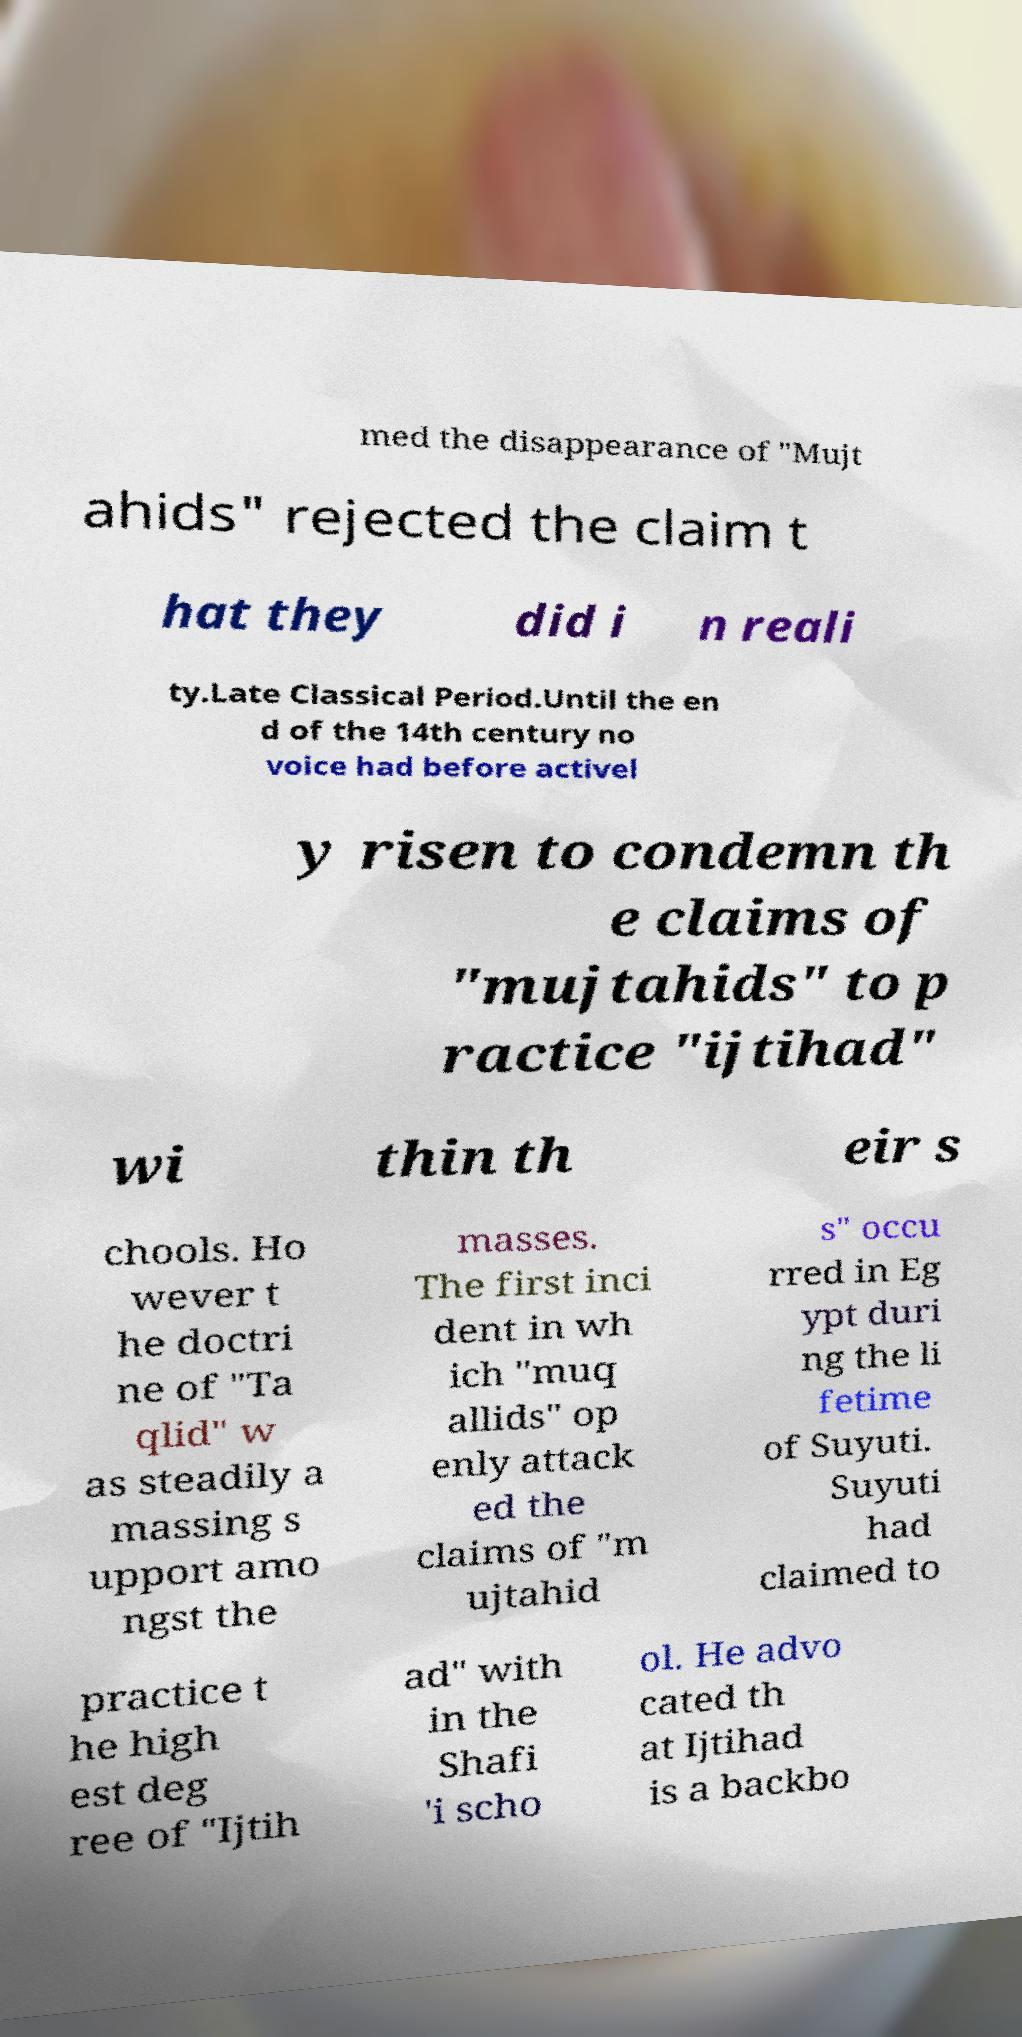There's text embedded in this image that I need extracted. Can you transcribe it verbatim? med the disappearance of "Mujt ahids" rejected the claim t hat they did i n reali ty.Late Classical Period.Until the en d of the 14th century no voice had before activel y risen to condemn th e claims of "mujtahids" to p ractice "ijtihad" wi thin th eir s chools. Ho wever t he doctri ne of "Ta qlid" w as steadily a massing s upport amo ngst the masses. The first inci dent in wh ich "muq allids" op enly attack ed the claims of "m ujtahid s" occu rred in Eg ypt duri ng the li fetime of Suyuti. Suyuti had claimed to practice t he high est deg ree of "Ijtih ad" with in the Shafi 'i scho ol. He advo cated th at Ijtihad is a backbo 